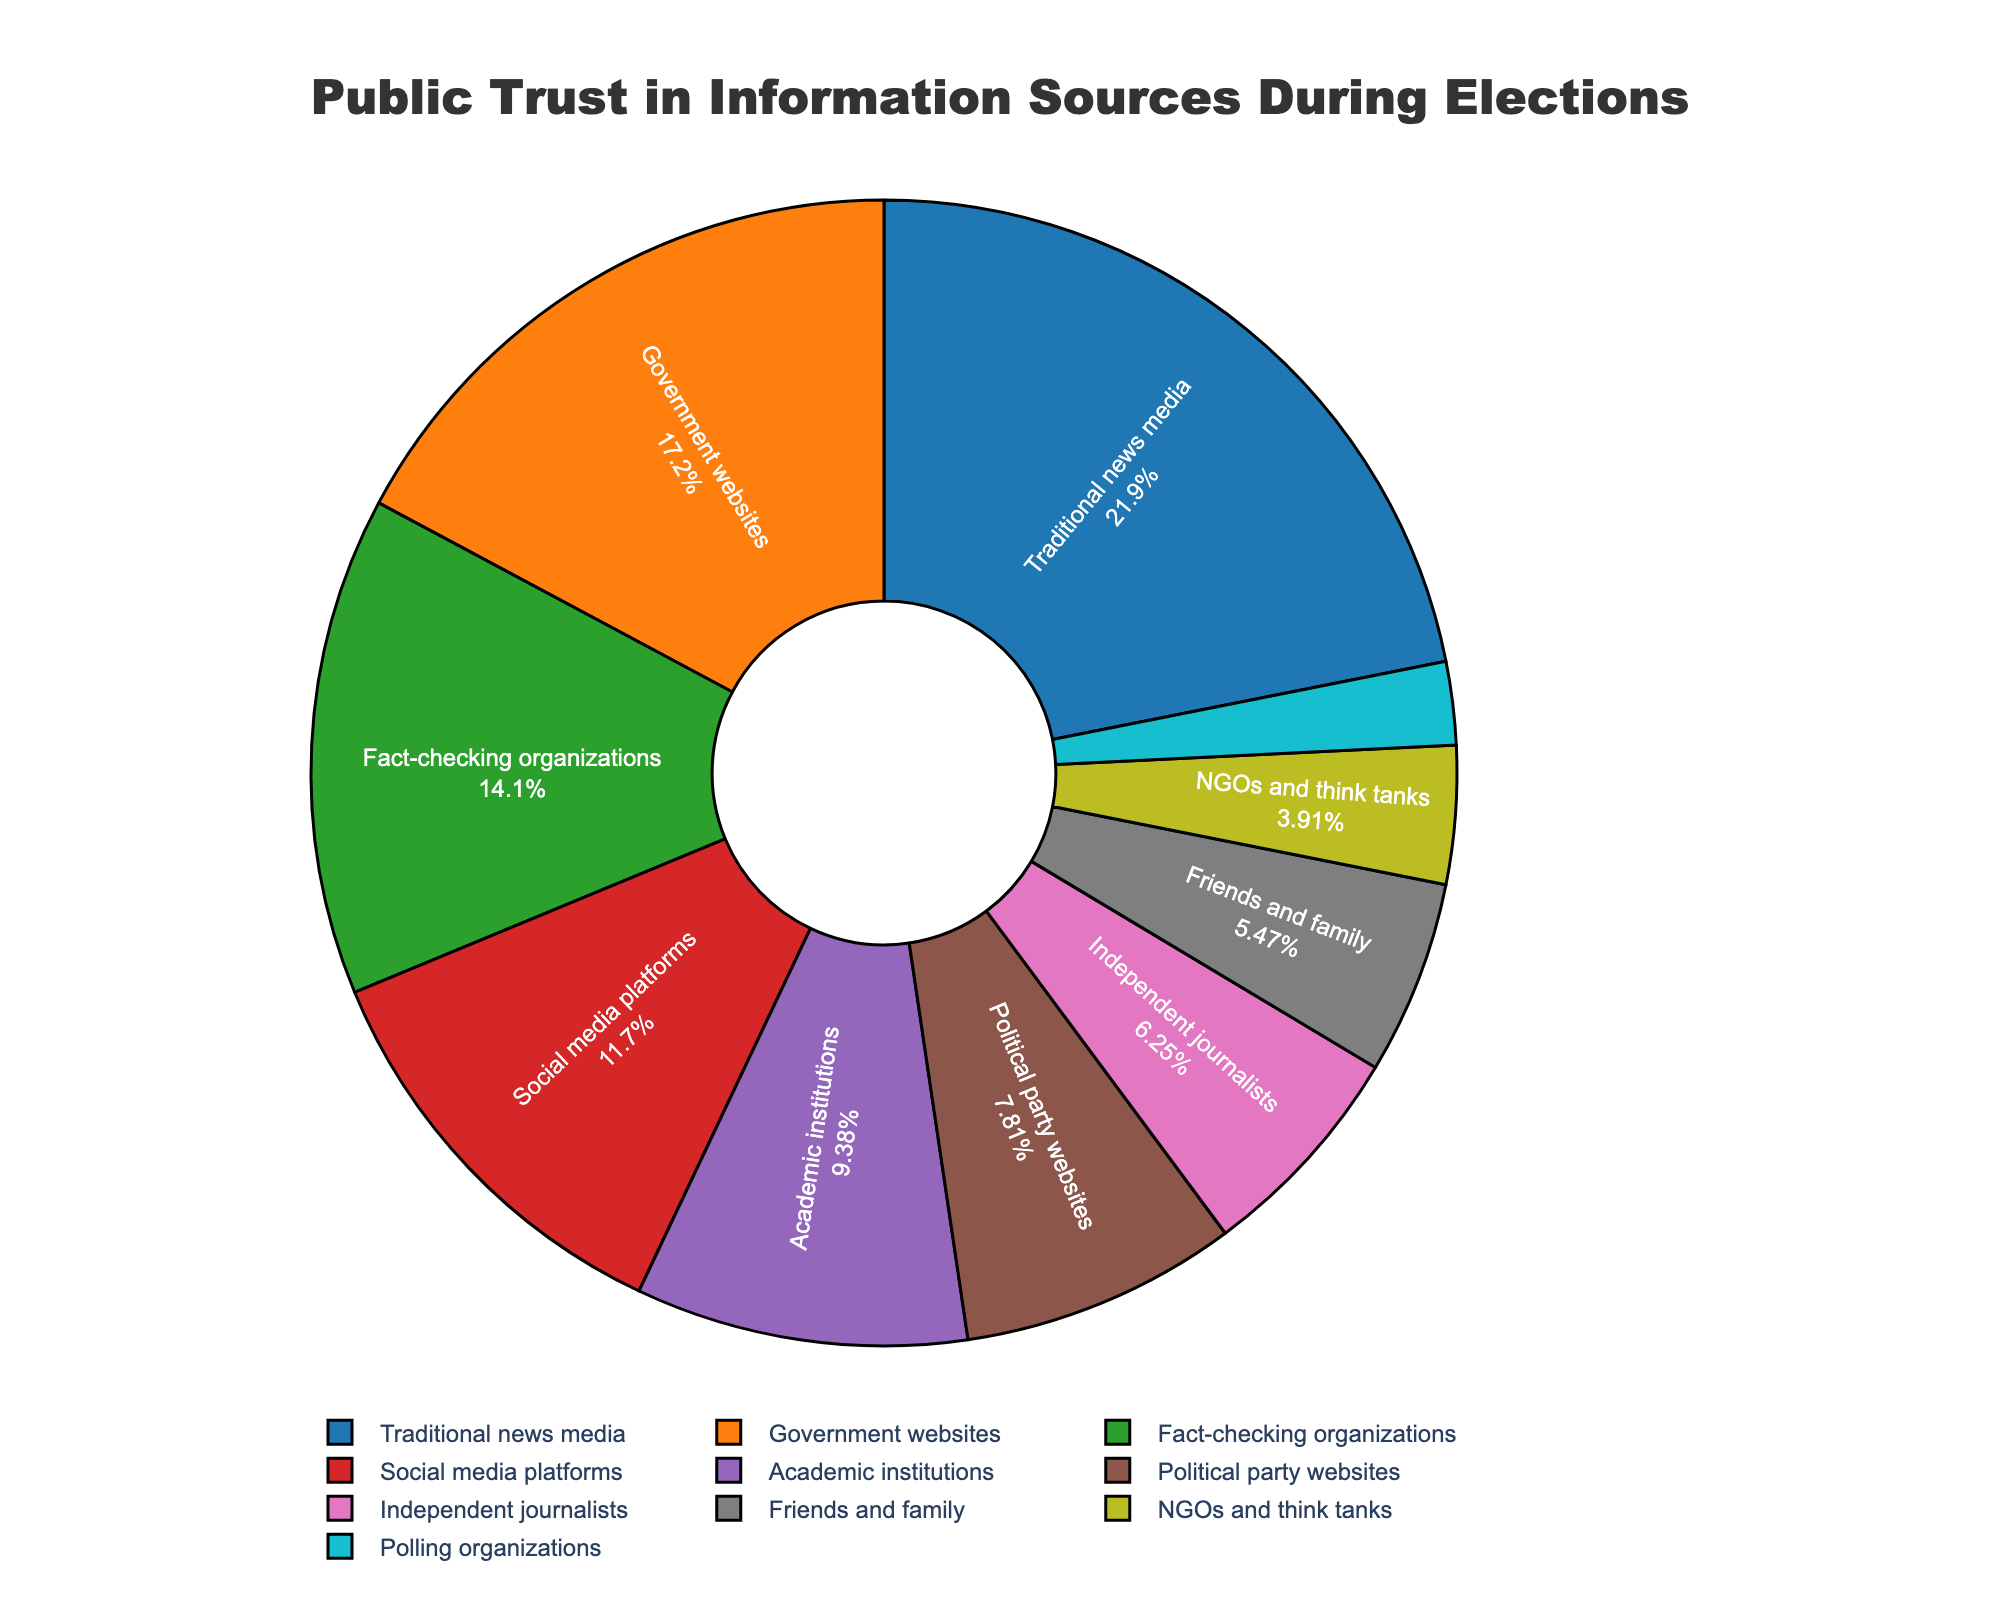Which source has the highest percentage of public trust during election periods? By visually analyzing the pie chart, it's clear that the largest segment is "Traditional news media" with 28%.
Answer: Traditional news media Which source has the lowest percentage of public trust during election periods? The smallest segment in the pie chart represents "Polling organizations," which has the lowest percentage at 3%.
Answer: Polling organizations How much more trust do government websites have compared to political party websites? The percentage for government websites is 22%, and for political party websites, it is 10%. The difference is 22% - 10% = 12%.
Answer: 12% What is the combined trust percentage for social media platforms and friends and family? The percentage for social media platforms is 15%, and for friends and family, it is 7%. Adding these together gives 15% + 7% = 22%.
Answer: 22% What is the difference between the trust percentages for academic institutions and independent journalists? The percentage for academic institutions is 12%, and for independent journalists, it is 8%. The difference is 12% - 8% = 4%.
Answer: 4% Are there more people who trust traditional news media or those who trust social media platforms and fact-checking organizations combined? The percentage for traditional news media is 28%. Combining social media platforms (15%) and fact-checking organizations (18%) gives 15% + 18% = 33%. 33% is greater than 28%.
Answer: Social media platforms and fact-checking organizations combined Which sources have a trust percentage greater than 20%? The segments representing more than 20% are "Traditional news media" (28%) and "Government websites" (22%).
Answer: Traditional news media, Government websites Is the trust in NGOs and think tanks higher or lower than the trust in polling organizations? NGOs and think tanks have a trust percentage of 5%, while polling organizations have 3%. So, NGOs and think tanks have a higher trust.
Answer: Higher What percentage of trust does fact-checking organizations garner? By visually inspecting the pie chart, the segment for fact-checking organizations shows 18%.
Answer: 18% Which source, government websites or academic institutions, has a larger trust percentage, and by how much? Government websites have a trust percentage of 22%, while academic institutions have 12%. The difference is 22% - 12% = 10%.
Answer: Government websites, by 10% 